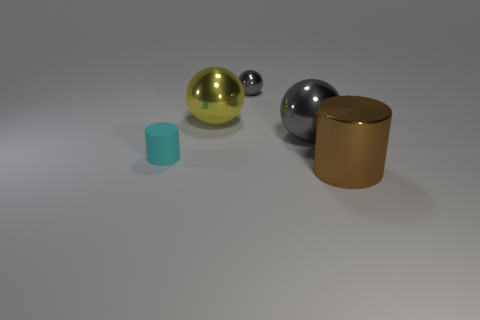Add 4 tiny blue metal cylinders. How many objects exist? 9 Subtract all cylinders. How many objects are left? 3 Subtract all large green matte balls. Subtract all large brown objects. How many objects are left? 4 Add 3 yellow things. How many yellow things are left? 4 Add 2 big yellow matte cylinders. How many big yellow matte cylinders exist? 2 Subtract 0 cyan cubes. How many objects are left? 5 